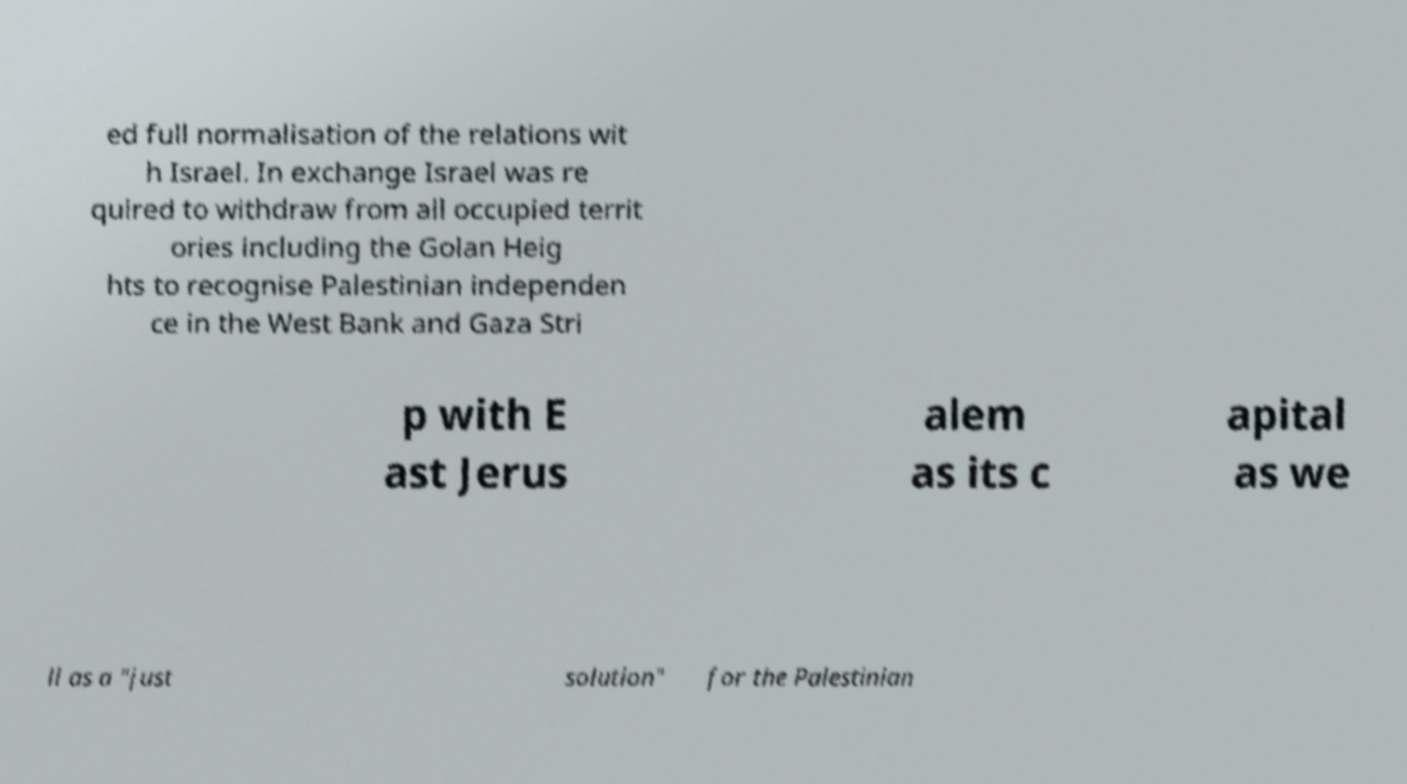I need the written content from this picture converted into text. Can you do that? ed full normalisation of the relations wit h Israel. In exchange Israel was re quired to withdraw from all occupied territ ories including the Golan Heig hts to recognise Palestinian independen ce in the West Bank and Gaza Stri p with E ast Jerus alem as its c apital as we ll as a "just solution" for the Palestinian 